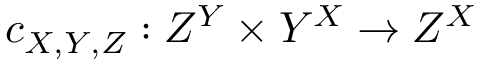<formula> <loc_0><loc_0><loc_500><loc_500>c _ { X , Y , Z } \colon Z ^ { Y } \times Y ^ { X } \to Z ^ { X }</formula> 